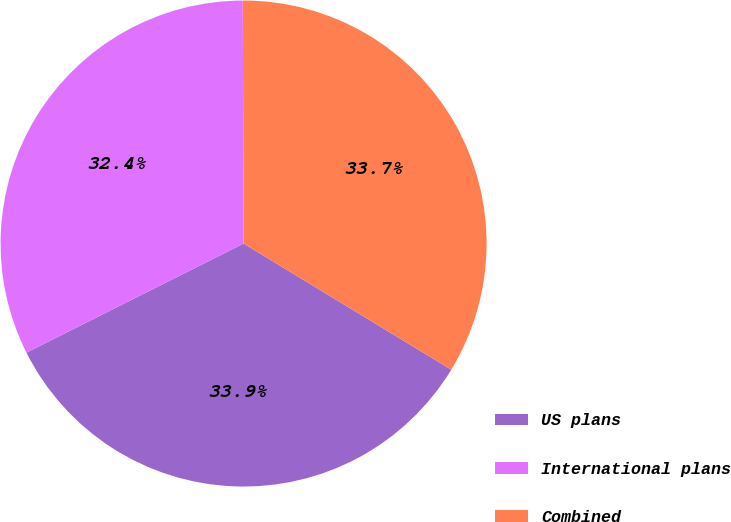Convert chart to OTSL. <chart><loc_0><loc_0><loc_500><loc_500><pie_chart><fcel>US plans<fcel>International plans<fcel>Combined<nl><fcel>33.9%<fcel>32.36%<fcel>33.74%<nl></chart> 